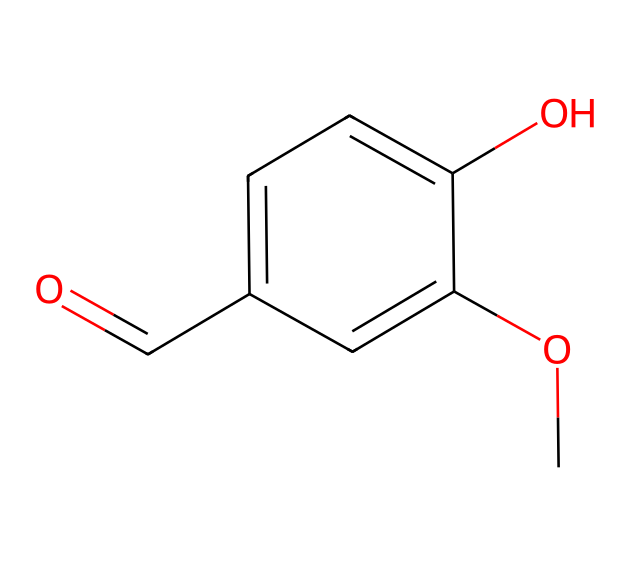how many carbon atoms are in the molecule? On examining the SMILES representation, we can count the number of carbon atoms explicitly present. The benzene ring (c1ccc) contributes six carbon atoms, and there is one carbon in the carbonyl group (O=C), bringing the total to seven.
Answer: seven what functional groups are present in this compound? The functional groups can be identified from the structure: there is a carbonyl group (O=C), a hydroxyl group (O), and a methoxy group (OC). Each of these groups has distinctive characteristics that can be confirmed from the SMILES notation.
Answer: carbonyl, hydroxyl, methoxy what is the molecular formula of the compound? To derive the molecular formula, we tally up the number of each type of atom present in the chemical's structure: 7 carbon (C), 8 hydrogen (H), and 4 oxygen (O) brings the formula to C7H8O4.
Answer: C7H8O4 what type of chemical is this compound? The presence of a benzene ring and several functional groups, including hydroxyl and methoxy, indicates that this compound is an aromatic organic compound. Aromatic compounds are characterized by their ring structure and resonance stability.
Answer: aromatic which part of the molecule is responsible for its sweet scent? The sweet scent is often associated with the methoxy group (–OCH3), which commonly imparts sweet aromas in many organic compounds. This group alters the overall scent profile as it contributes to the overall volatility and scent characteristics.
Answer: methoxy group is this compound likely to be water-soluble? The presence of multiple polar functional groups, particularly the hydroxyl group, suggests that this compound has the capacity to form hydrogen bonds with water, making it likely to be water-soluble.
Answer: likely does this compound have any isomers? The presence of several functional groups and the molecular formula C7H8O4 indicates that it is possible to have structural isomers that share the same formula but differ in connectivity of atoms or arrangement of the functional groups.
Answer: yes 